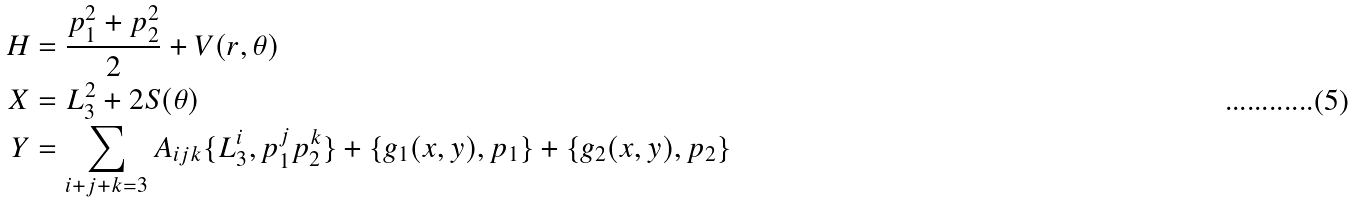<formula> <loc_0><loc_0><loc_500><loc_500>H & = \frac { p _ { 1 } ^ { 2 } + p _ { 2 } ^ { 2 } } { 2 } + V ( r , \theta ) \\ X & = L _ { 3 } ^ { 2 } + 2 S ( \theta ) \\ Y & = \sum _ { i + j + k = 3 } A _ { i j k } \{ L _ { 3 } ^ { i } , p _ { 1 } ^ { j } p _ { 2 } ^ { k } \} + \{ g _ { 1 } ( x , y ) , p _ { 1 } \} + \{ g _ { 2 } ( x , y ) , p _ { 2 } \}</formula> 